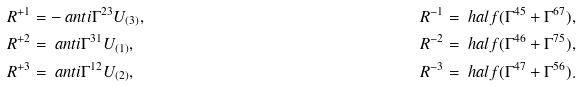<formula> <loc_0><loc_0><loc_500><loc_500>R ^ { + 1 } & = - \ a n t i { \Gamma ^ { 2 3 } } { U _ { ( 3 ) } } , & R ^ { - 1 } & = \ h a l f ( \Gamma ^ { 4 5 } + \Gamma ^ { 6 7 } ) , \\ R ^ { + 2 } & = \ a n t i { \Gamma ^ { 3 1 } } { U _ { ( 1 ) } } , & R ^ { - 2 } & = \ h a l f ( \Gamma ^ { 4 6 } + \Gamma ^ { 7 5 } ) , \\ R ^ { + 3 } & = \ a n t i { \Gamma ^ { 1 2 } } { U _ { ( 2 ) } } , & R ^ { - 3 } & = \ h a l f ( \Gamma ^ { 4 7 } + \Gamma ^ { 5 6 } ) .</formula> 